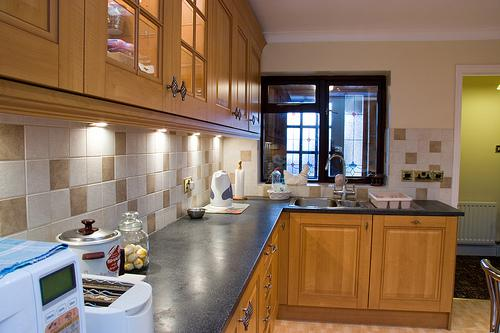Question: where was the picture taken?
Choices:
A. Kitchen.
B. Living room.
C. Bedroom.
D. Hallway.
Answer with the letter. Answer: A Question: what color is the microwave?
Choices:
A. Green.
B. Blue.
C. White.
D. Red.
Answer with the letter. Answer: C 